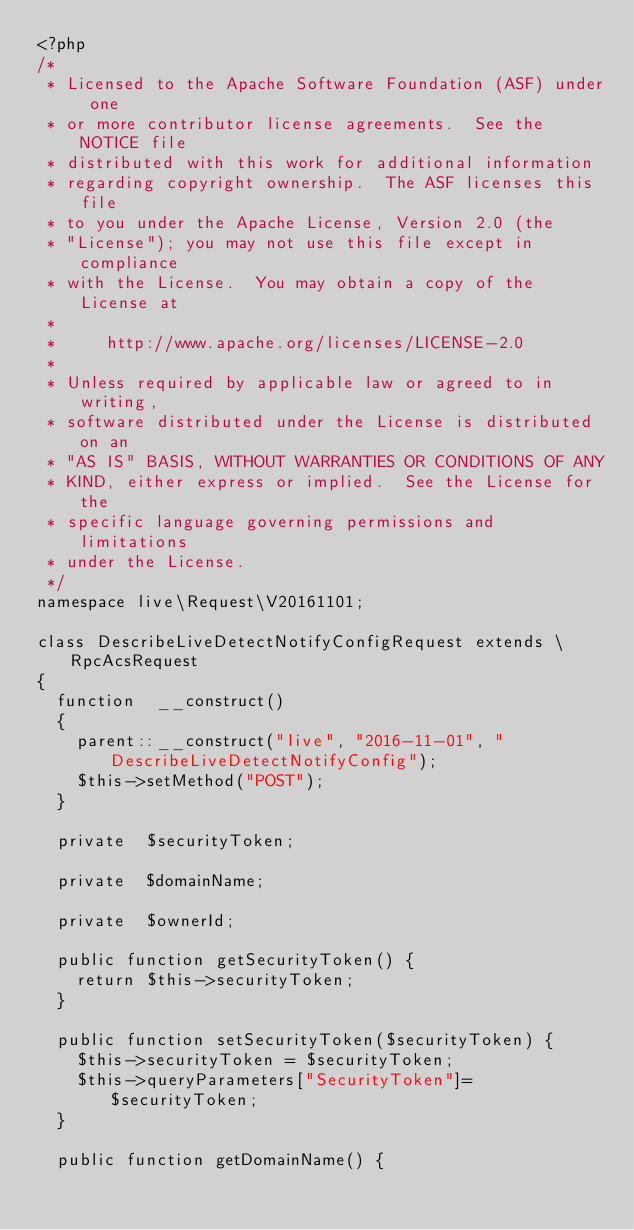Convert code to text. <code><loc_0><loc_0><loc_500><loc_500><_PHP_><?php
/*
 * Licensed to the Apache Software Foundation (ASF) under one
 * or more contributor license agreements.  See the NOTICE file
 * distributed with this work for additional information
 * regarding copyright ownership.  The ASF licenses this file
 * to you under the Apache License, Version 2.0 (the
 * "License"); you may not use this file except in compliance
 * with the License.  You may obtain a copy of the License at
 *
 *     http://www.apache.org/licenses/LICENSE-2.0
 *
 * Unless required by applicable law or agreed to in writing,
 * software distributed under the License is distributed on an
 * "AS IS" BASIS, WITHOUT WARRANTIES OR CONDITIONS OF ANY
 * KIND, either express or implied.  See the License for the
 * specific language governing permissions and limitations
 * under the License.
 */
namespace live\Request\V20161101;

class DescribeLiveDetectNotifyConfigRequest extends \RpcAcsRequest
{
	function  __construct()
	{
		parent::__construct("live", "2016-11-01", "DescribeLiveDetectNotifyConfig");
		$this->setMethod("POST");
	}

	private  $securityToken;

	private  $domainName;

	private  $ownerId;

	public function getSecurityToken() {
		return $this->securityToken;
	}

	public function setSecurityToken($securityToken) {
		$this->securityToken = $securityToken;
		$this->queryParameters["SecurityToken"]=$securityToken;
	}

	public function getDomainName() {</code> 